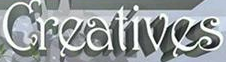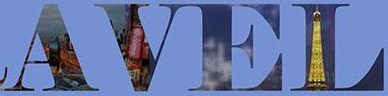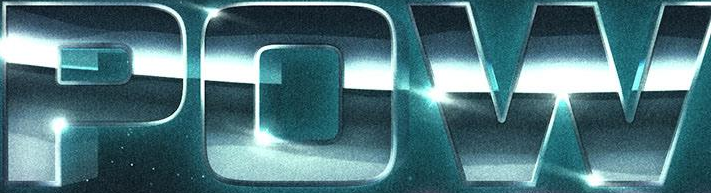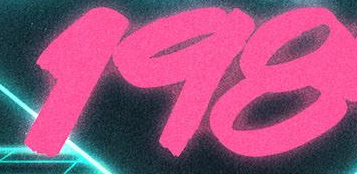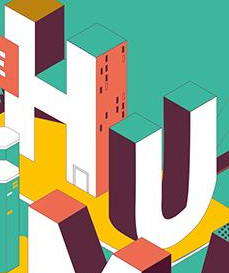Read the text from these images in sequence, separated by a semicolon. Creatives; AVEL; POW; 198; HU 